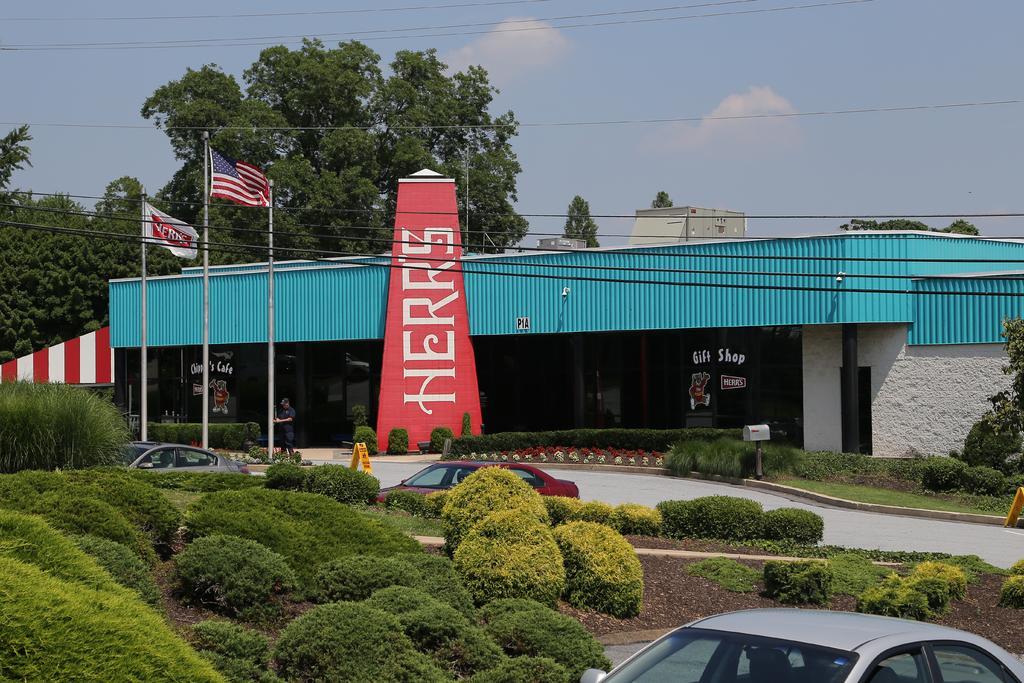How would you summarize this image in a sentence or two? In the image we can see a store, pole, flag, vehicle, soil, plants, grass, electric wires, trees and a cloudy blue sky. We can even see a person standing and wearing clothes. 